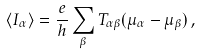<formula> <loc_0><loc_0><loc_500><loc_500>\langle I _ { \alpha } \rangle = \frac { e } { h } \sum _ { \beta } T _ { \alpha \beta } ( \mu _ { \alpha } - \mu _ { \beta } ) \, ,</formula> 